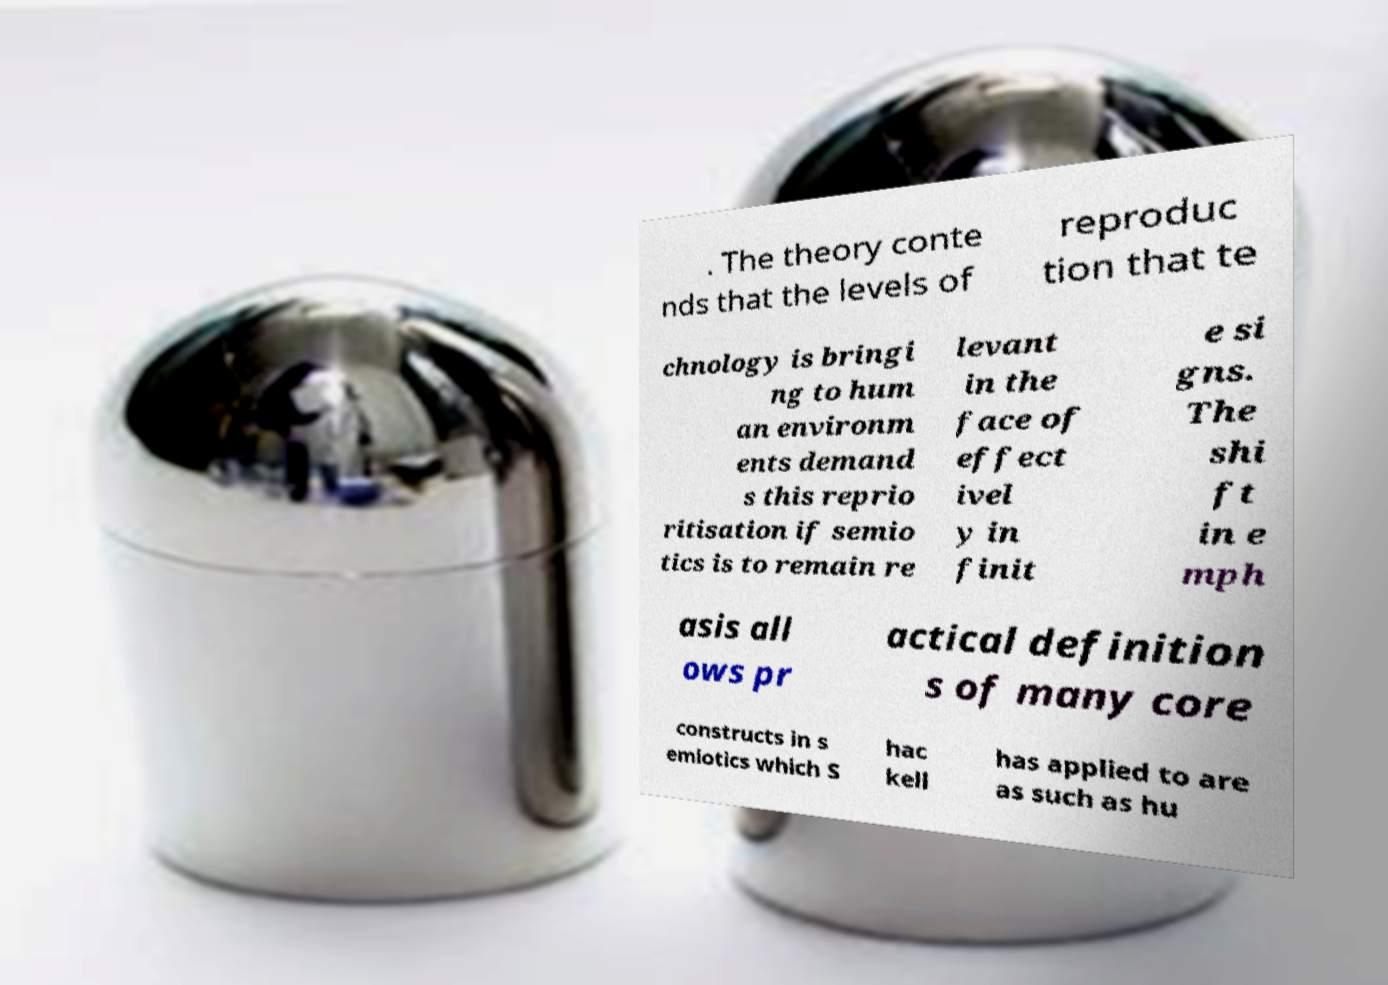I need the written content from this picture converted into text. Can you do that? . The theory conte nds that the levels of reproduc tion that te chnology is bringi ng to hum an environm ents demand s this reprio ritisation if semio tics is to remain re levant in the face of effect ivel y in finit e si gns. The shi ft in e mph asis all ows pr actical definition s of many core constructs in s emiotics which S hac kell has applied to are as such as hu 